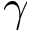Convert formula to latex. <formula><loc_0><loc_0><loc_500><loc_500>\gamma</formula> 